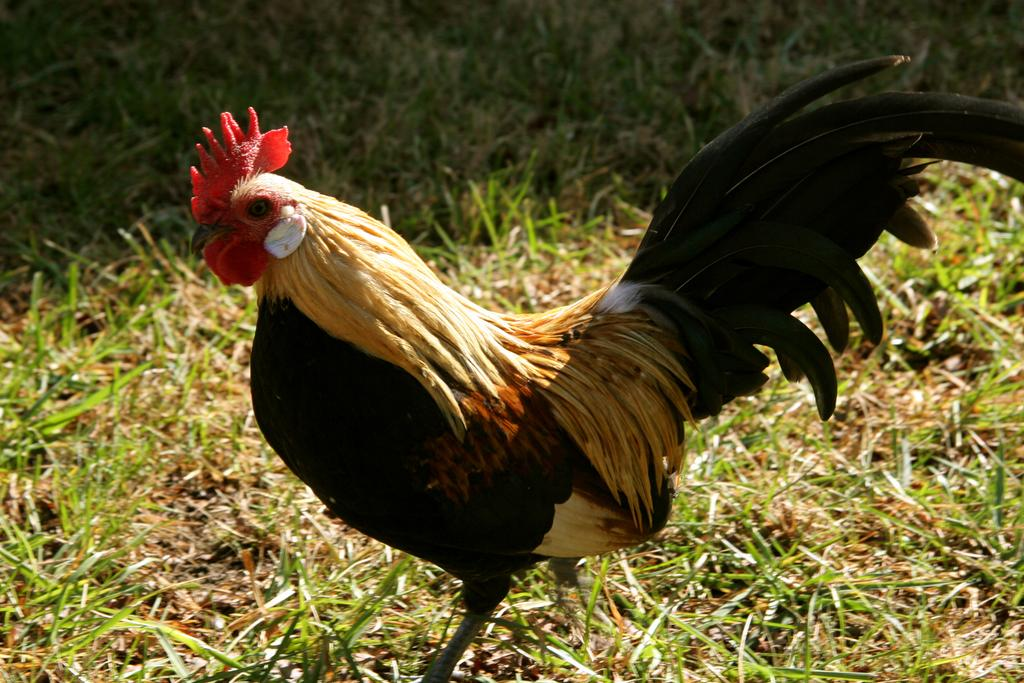What type of animal is in the image? There is a cock in the image. What is the cock doing in the image? The cock is standing on the ground. What type of surface is the cock standing on? There is grass on the ground in the image. What type of pets can be seen interacting with the cock in the image? There are no pets present in the image, and therefore no interaction with the cock can be observed. 